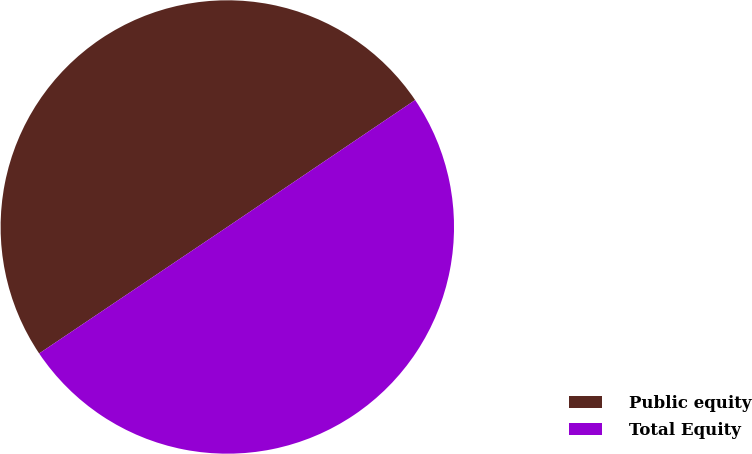<chart> <loc_0><loc_0><loc_500><loc_500><pie_chart><fcel>Public equity<fcel>Total Equity<nl><fcel>49.96%<fcel>50.04%<nl></chart> 